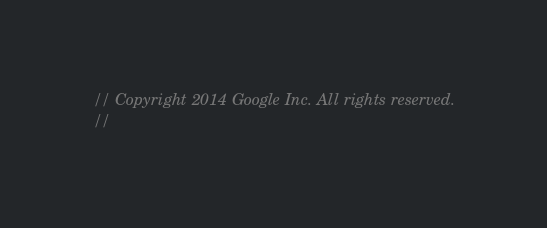<code> <loc_0><loc_0><loc_500><loc_500><_C_>// Copyright 2014 Google Inc. All rights reserved.
//</code> 